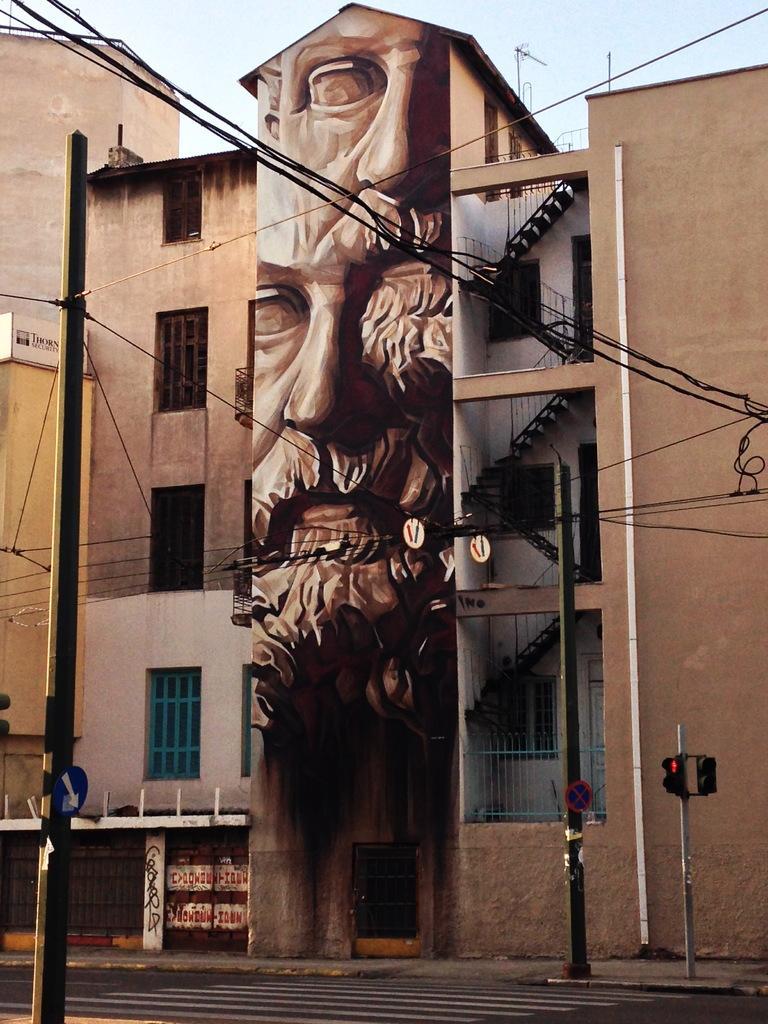Describe this image in one or two sentences. In this image there is a building in the middle. There is a wall poster to its wall. On the right side there are steps. At the top there is the sky. On the left side there is a pole to which there are wires. At the bottom there is a road. On the footpath there is a signal light and an electric pole. In the middle there is a door. 